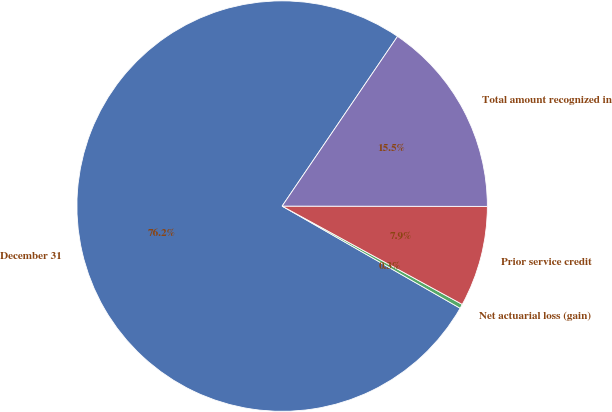Convert chart. <chart><loc_0><loc_0><loc_500><loc_500><pie_chart><fcel>December 31<fcel>Net actuarial loss (gain)<fcel>Prior service credit<fcel>Total amount recognized in<nl><fcel>76.22%<fcel>0.34%<fcel>7.93%<fcel>15.52%<nl></chart> 